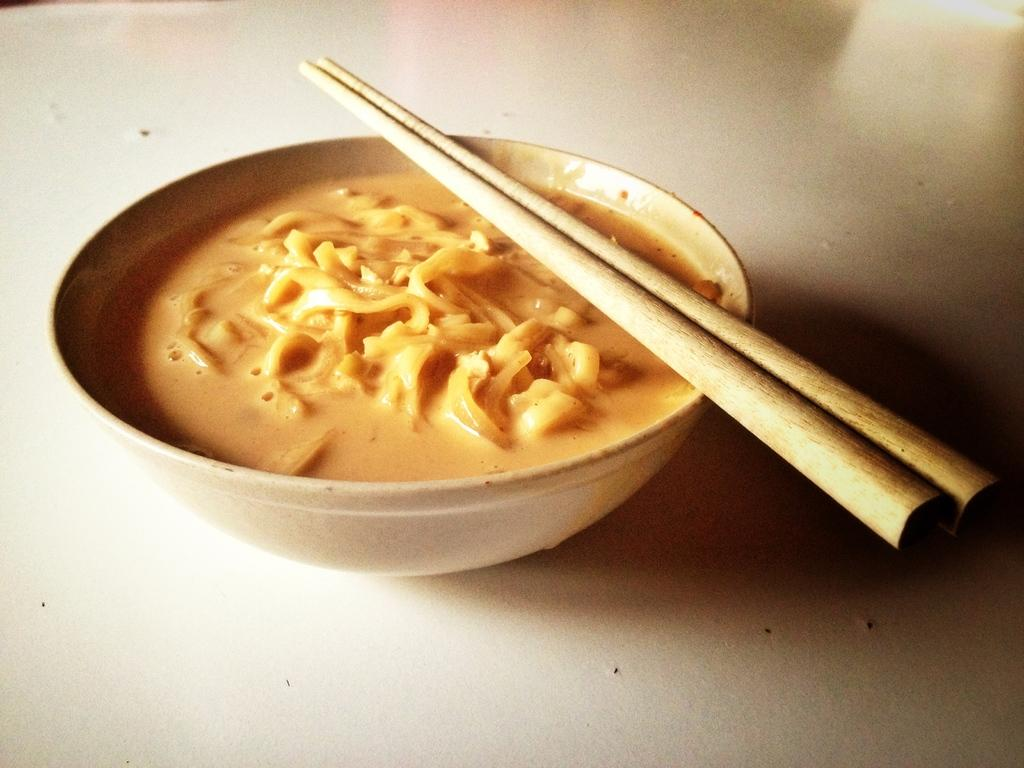What is in the bowl that is visible in the image? The bowl contains curry. What utensil is placed with the bowl? Chopsticks are placed on the bowl. What type of bulb is used to light the curry in the image? There is no bulb present in the image, and the curry is not being lit. 